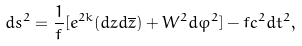Convert formula to latex. <formula><loc_0><loc_0><loc_500><loc_500>d s ^ { 2 } = \frac { 1 } { f } [ e ^ { 2 k } ( d z d \overline { z } ) + W ^ { 2 } d \varphi ^ { 2 } ] - f c ^ { 2 } d t ^ { 2 } ,</formula> 